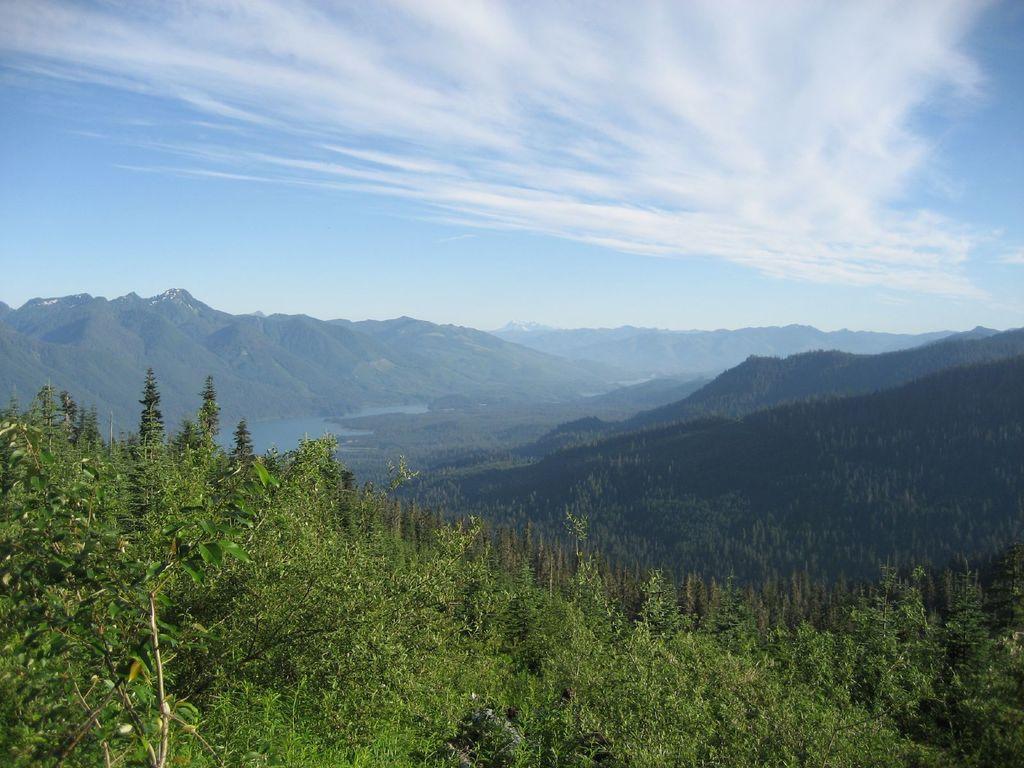Could you give a brief overview of what you see in this image? In this image I can see few trees which are green in color, the water and few mountains. In the background I can see the sky. 